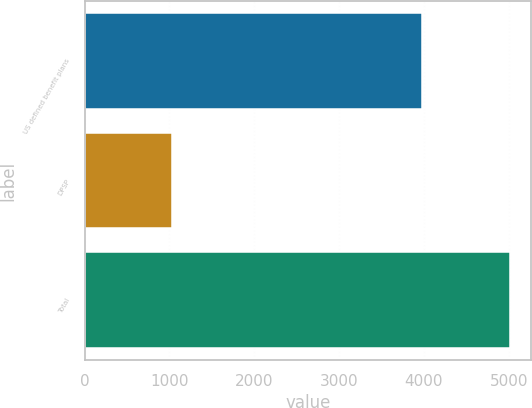Convert chart. <chart><loc_0><loc_0><loc_500><loc_500><bar_chart><fcel>US defined benefit plans<fcel>DPSP<fcel>Total<nl><fcel>3982<fcel>1029<fcel>5011<nl></chart> 